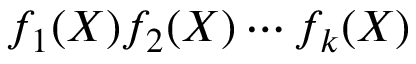<formula> <loc_0><loc_0><loc_500><loc_500>f _ { 1 } ( X ) f _ { 2 } ( X ) \cdots f _ { k } ( X )</formula> 